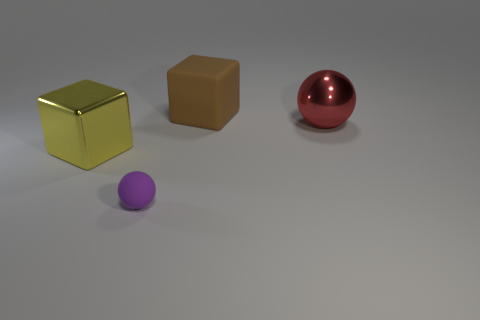Add 3 large cubes. How many objects exist? 7 Subtract 0 cyan cubes. How many objects are left? 4 Subtract all brown rubber blocks. Subtract all big spheres. How many objects are left? 2 Add 3 large yellow metal cubes. How many large yellow metal cubes are left? 4 Add 2 purple cylinders. How many purple cylinders exist? 2 